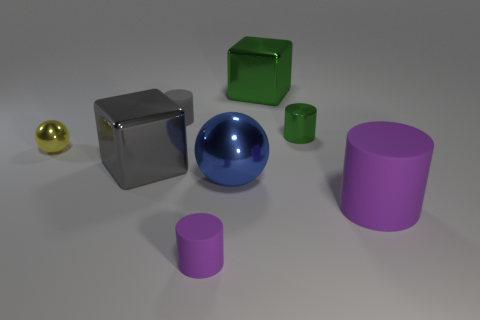Add 2 green blocks. How many objects exist? 10 Subtract all cubes. How many objects are left? 6 Add 1 purple rubber things. How many purple rubber things are left? 3 Add 8 tiny yellow metal things. How many tiny yellow metal things exist? 9 Subtract 0 red spheres. How many objects are left? 8 Subtract all big green matte cylinders. Subtract all large blue metallic things. How many objects are left? 7 